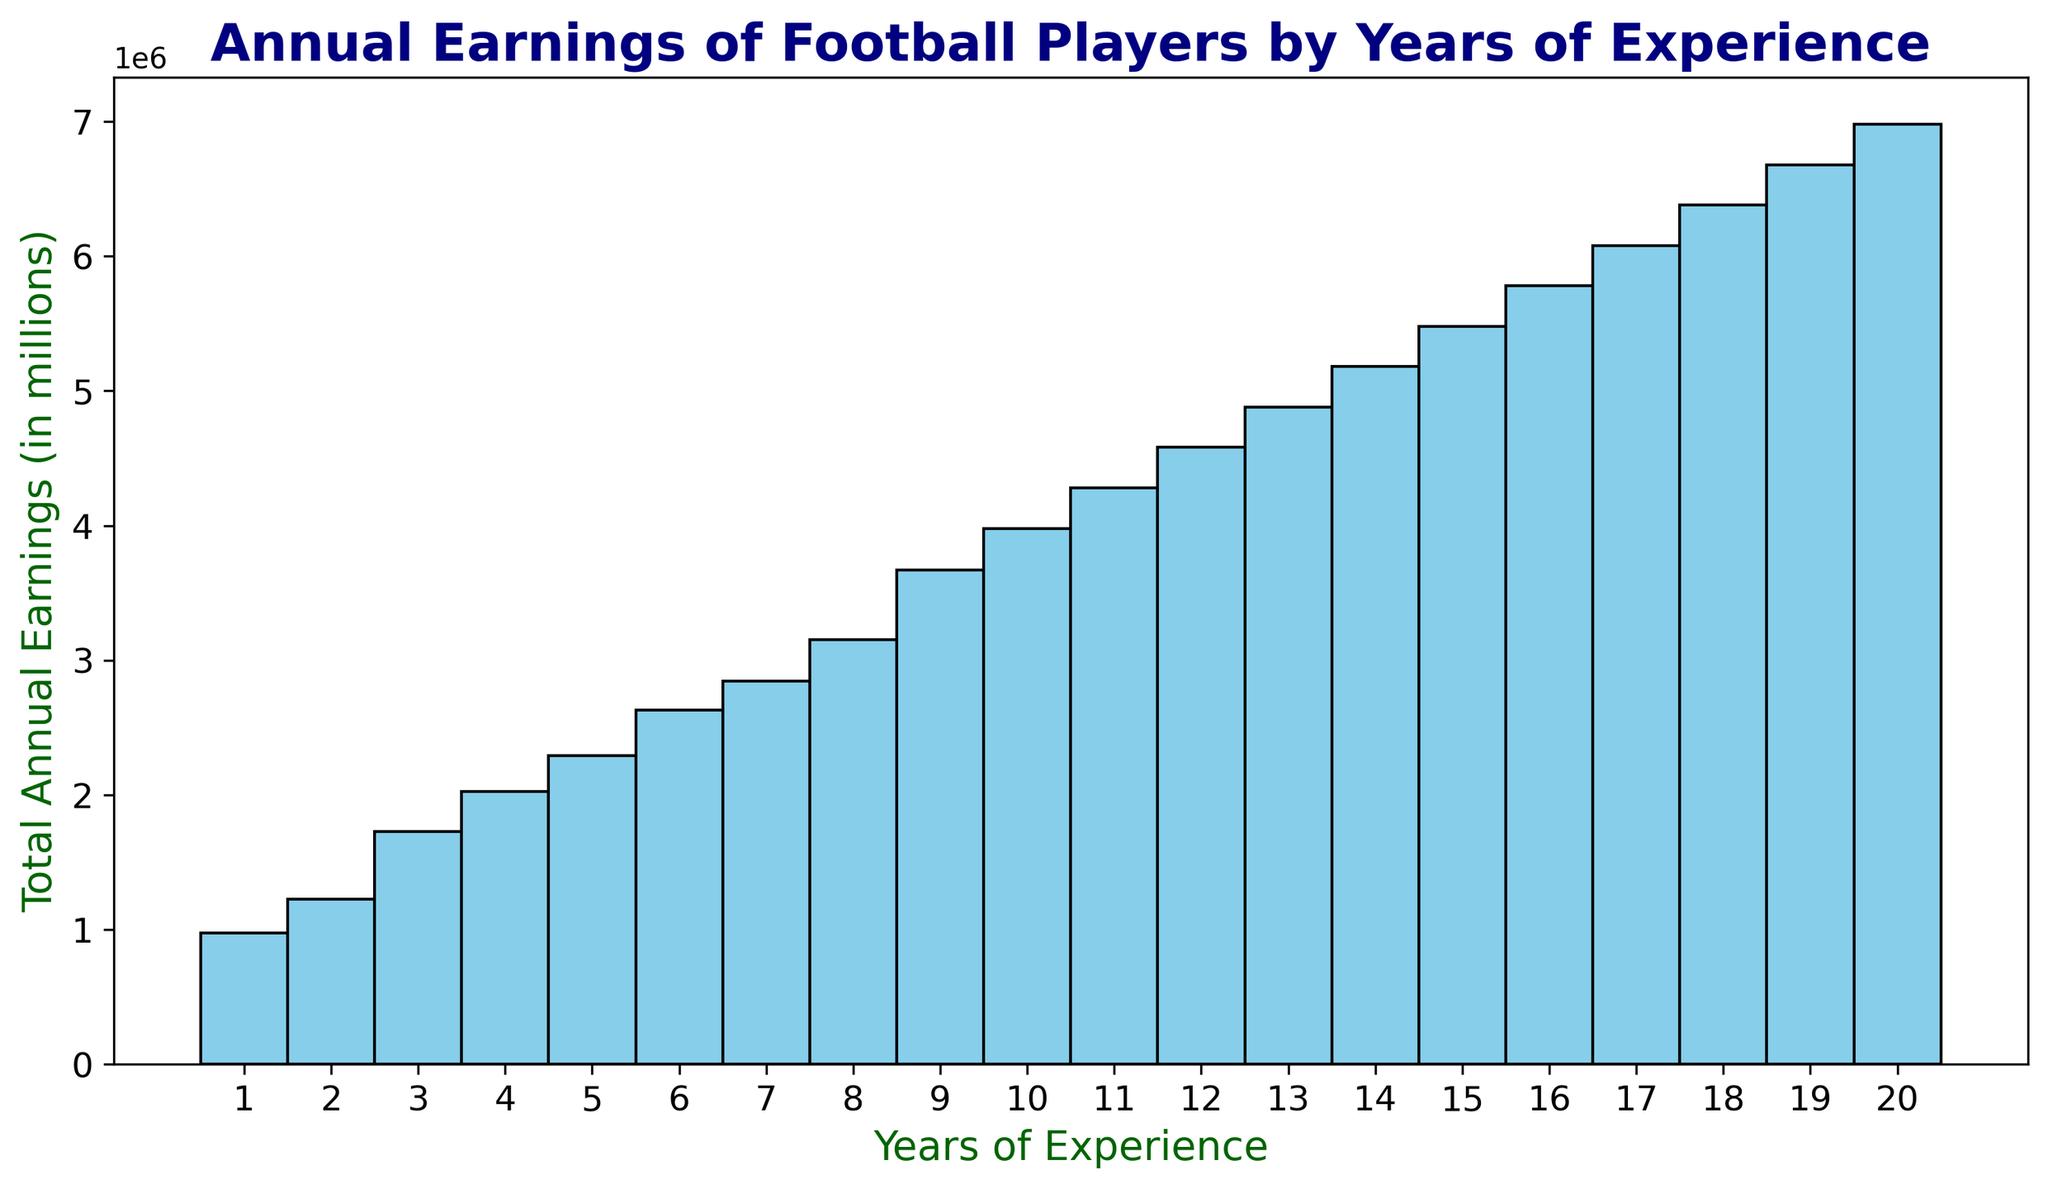What's the total annual earnings for players with 3 years of experience? To find the total annual earnings for players with 3 years of experience, we sum up the earnings for all players with 3 years of experience. 550000 + 600000 + 580000 = 1730000
Answer: 1730000 Which experience level has the highest total annual earnings? By visually inspecting the histogram, the bin with the highest bar indicates the highest total annual earnings. The bar height for 8 years of experience appears to be the highest.
Answer: 8 years Is there an increase or decrease in total annual earnings from 2 to 5 years of experience? To determine this, compare the heights of the histogram bars from 2 to 5 years of experience. The height increases from 2 to 5 years, indicating an increase in total annual earnings.
Answer: Increase Are the total earnings for players with 10 years of experience more than those with 5 years of experience? Visually compare the height of the bars at 10 and 5 years of experience. The bar height for 10 years is higher than that for 5 years.
Answer: Yes What is the average annual earnings for players with 7 years of experience? Calculate the average by summing the annual earnings for 7 years of experience and dividing by the number of players. (975000 + 920000 + 950000) / 3 = 948333.33
Answer: 948333.33 Compare the bars for 14 and 15 years of experience. Which one is taller? By visually inspecting the histogram, the bar for 15 years of experience is taller than that for 14 years of experience.
Answer: 15 years Do players with 20 years of experience have the highest total annual earnings? Inspect the histogram bar for 20 years of experience. It is not the highest; players with 8 years of experience have the highest total earnings.
Answer: No What is the trend in annual earnings as players gain more years of experience? Visually, the histogram shows that the bar heights generally increase as the years of experience increase, indicating a trend of increasing total annual earnings with more years of experience.
Answer: Increasing 